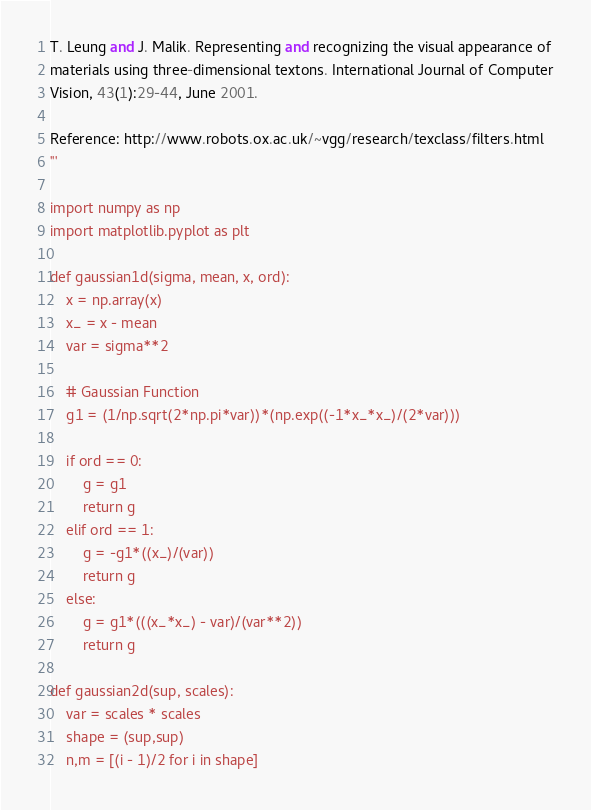Convert code to text. <code><loc_0><loc_0><loc_500><loc_500><_Python_>
T. Leung and J. Malik. Representing and recognizing the visual appearance of
materials using three-dimensional textons. International Journal of Computer
Vision, 43(1):29-44, June 2001.

Reference: http://www.robots.ox.ac.uk/~vgg/research/texclass/filters.html
'''

import numpy as np
import matplotlib.pyplot as plt

def gaussian1d(sigma, mean, x, ord):
    x = np.array(x)
    x_ = x - mean
    var = sigma**2

    # Gaussian Function
    g1 = (1/np.sqrt(2*np.pi*var))*(np.exp((-1*x_*x_)/(2*var)))

    if ord == 0:
        g = g1
        return g
    elif ord == 1:
        g = -g1*((x_)/(var))
        return g
    else:
        g = g1*(((x_*x_) - var)/(var**2))
        return g

def gaussian2d(sup, scales):
    var = scales * scales
    shape = (sup,sup)
    n,m = [(i - 1)/2 for i in shape]</code> 